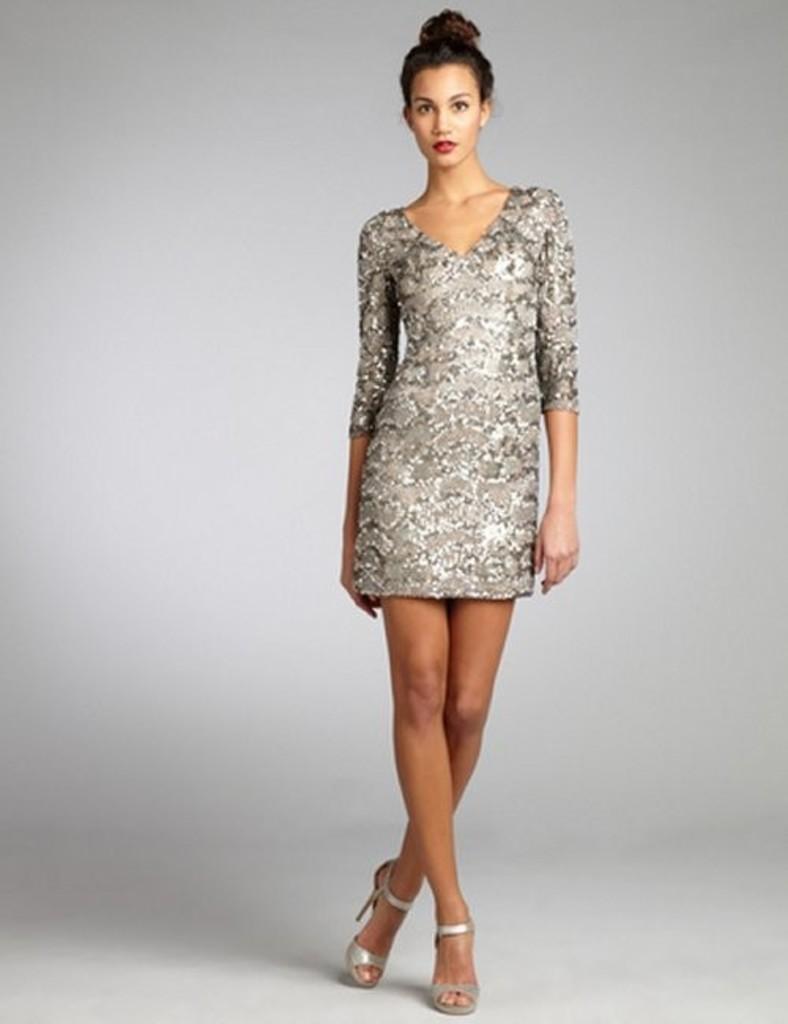Could you give a brief overview of what you see in this image? In this image we can see a woman standing on the floor. 